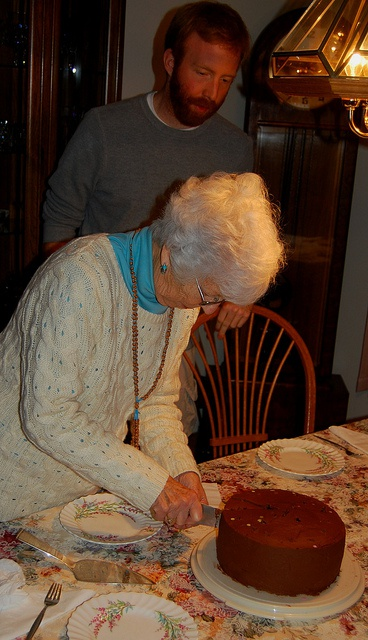Describe the objects in this image and their specific colors. I can see people in black, gray, and darkgray tones, dining table in black, maroon, tan, gray, and brown tones, people in black, maroon, and gray tones, chair in black, maroon, and brown tones, and cake in black, maroon, and brown tones in this image. 